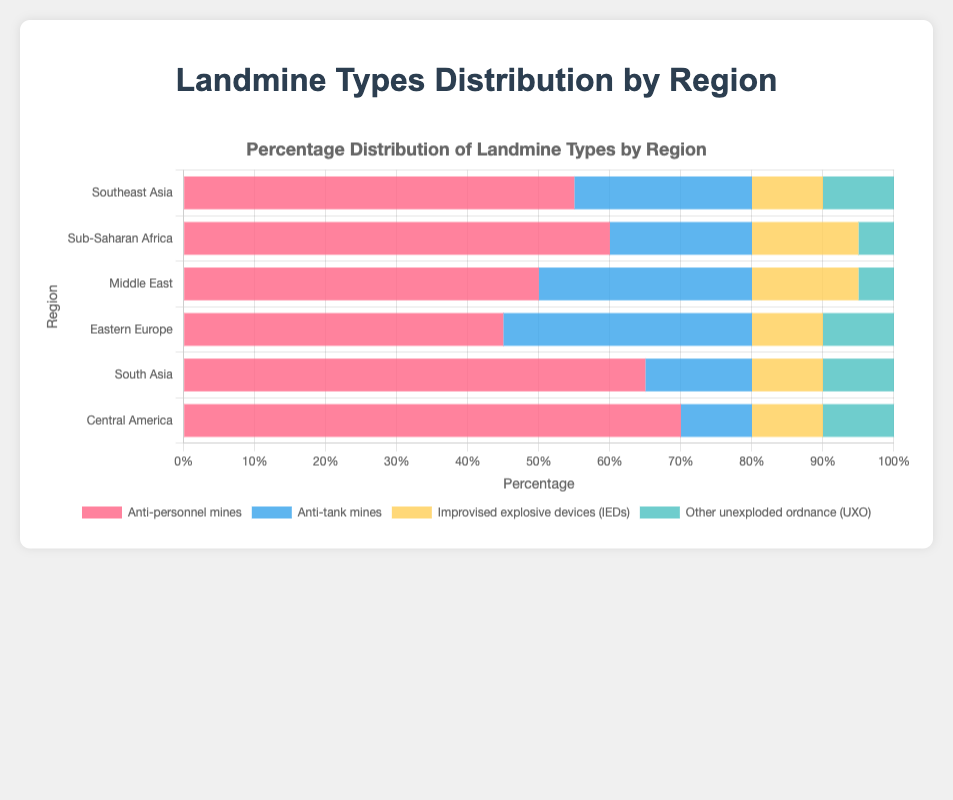What is the percentage of anti-personnel mines found in Sub-Saharan Africa? Sub-Saharan Africa has a dedicated bar for anti-personnel mines. The given percentage is 60%.
Answer: 60% Which region has the highest percentage of anti-tank mines? Compare the lengths of the bars representing anti-tank mines in all regions. Eastern Europe has the longest bar at 35%.
Answer: Eastern Europe What is the combined percentage for IEDs and UXO in Southeast Asia? Sum the percentage values for IEDs (10%) and UXO (10%) in Southeast Asia. The combined percentage is 10% + 10% = 20%.
Answer: 20% Which region has the lowest percentage of UXO? Compare the lengths of the UXO bars in all regions. Sub-Saharan Africa and the Middle East both have the shortest bar at 5%.
Answer: Sub-Saharan Africa and Middle East Which region has the most balanced distribution of the four landmine types? Analyze which region's bars are more equal in length. For instance, Eastern Europe has 45%, 35%, 10%, and 10%, which are relatively close to each other compared to other regions.
Answer: Eastern Europe Is the percentage of anti-personnel mines higher in South Asia or Central America? Compare the bar lengths for anti-personnel mines in South Asia (65%) and Central America (70%).
Answer: Central America What is the average percentage of anti-tank mines across all regions? Sum the percentages of anti-tank mines in all regions (25% + 20% + 30% + 35% + 15% + 10% = 135%) and divide by the number of regions (6). The average is 135/6 = 22.5%.
Answer: 22.5% By how much does the percentage of IEDs in the Middle East exceed that in Southeast Asia? Subtract the percentage of IEDs in Southeast Asia (10%) from that in the Middle East (15%). The difference is 15% - 10% = 5%.
Answer: 5% Which landmine type appears most frequently in Central America? Analyze the tallest bar in Central America, which represents anti-personnel mines at 70%.
Answer: Anti-personnel mines 